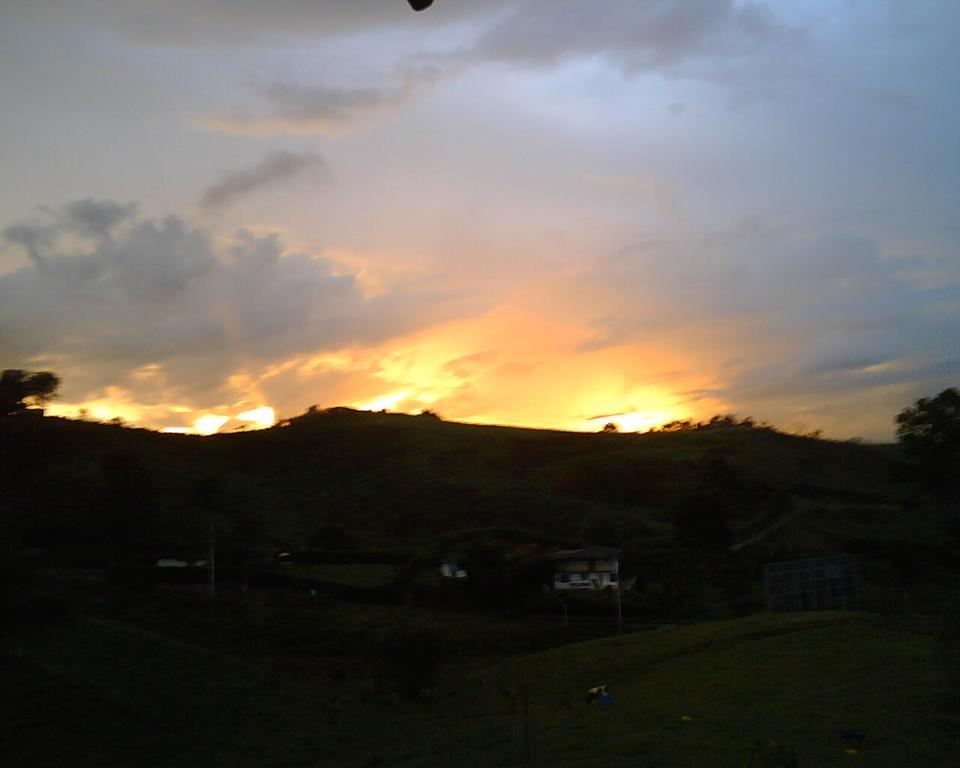What type of natural vegetation can be seen in the image? There are trees in the image. What type of structures are visible in the image? There are houses in the image. What geographical feature can be seen in the background of the image? There are mountains in the image. What is visible at the top of the image? The sky is visible at the top of the image. What rate do the houses in the image stop growing? The houses in the image are not growing, so there is no rate at which they stop growing. What way do the trees in the image communicate with each other? Trees do not communicate with each other in the way that humans do, so there is no way for them to communicate in the image. 